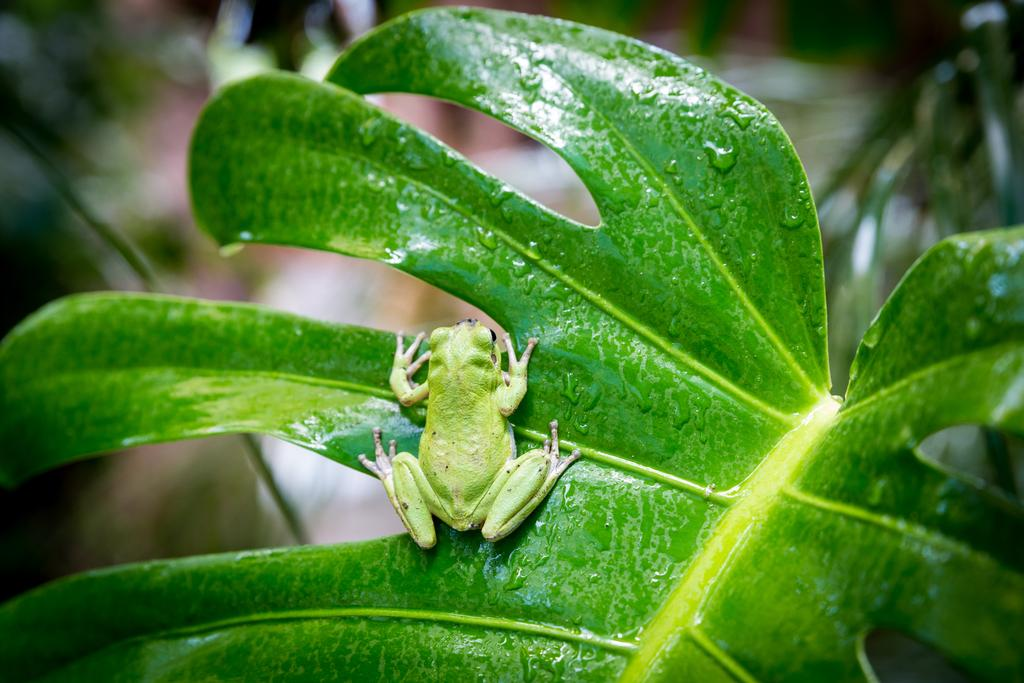What type of animal is in the image? There is a green frog in the image. What is the frog standing on? The frog is standing on a leaf. What can be seen on the right side of the image? There is a plant on the right side of the image. What type of houses can be seen in the background of the image? There are no houses present in the image; it features a green frog standing on a leaf. Can you tell me how many times the frog whistles in the image? There is no indication in the image that the frog is whistling, so it cannot be determined from the picture. 